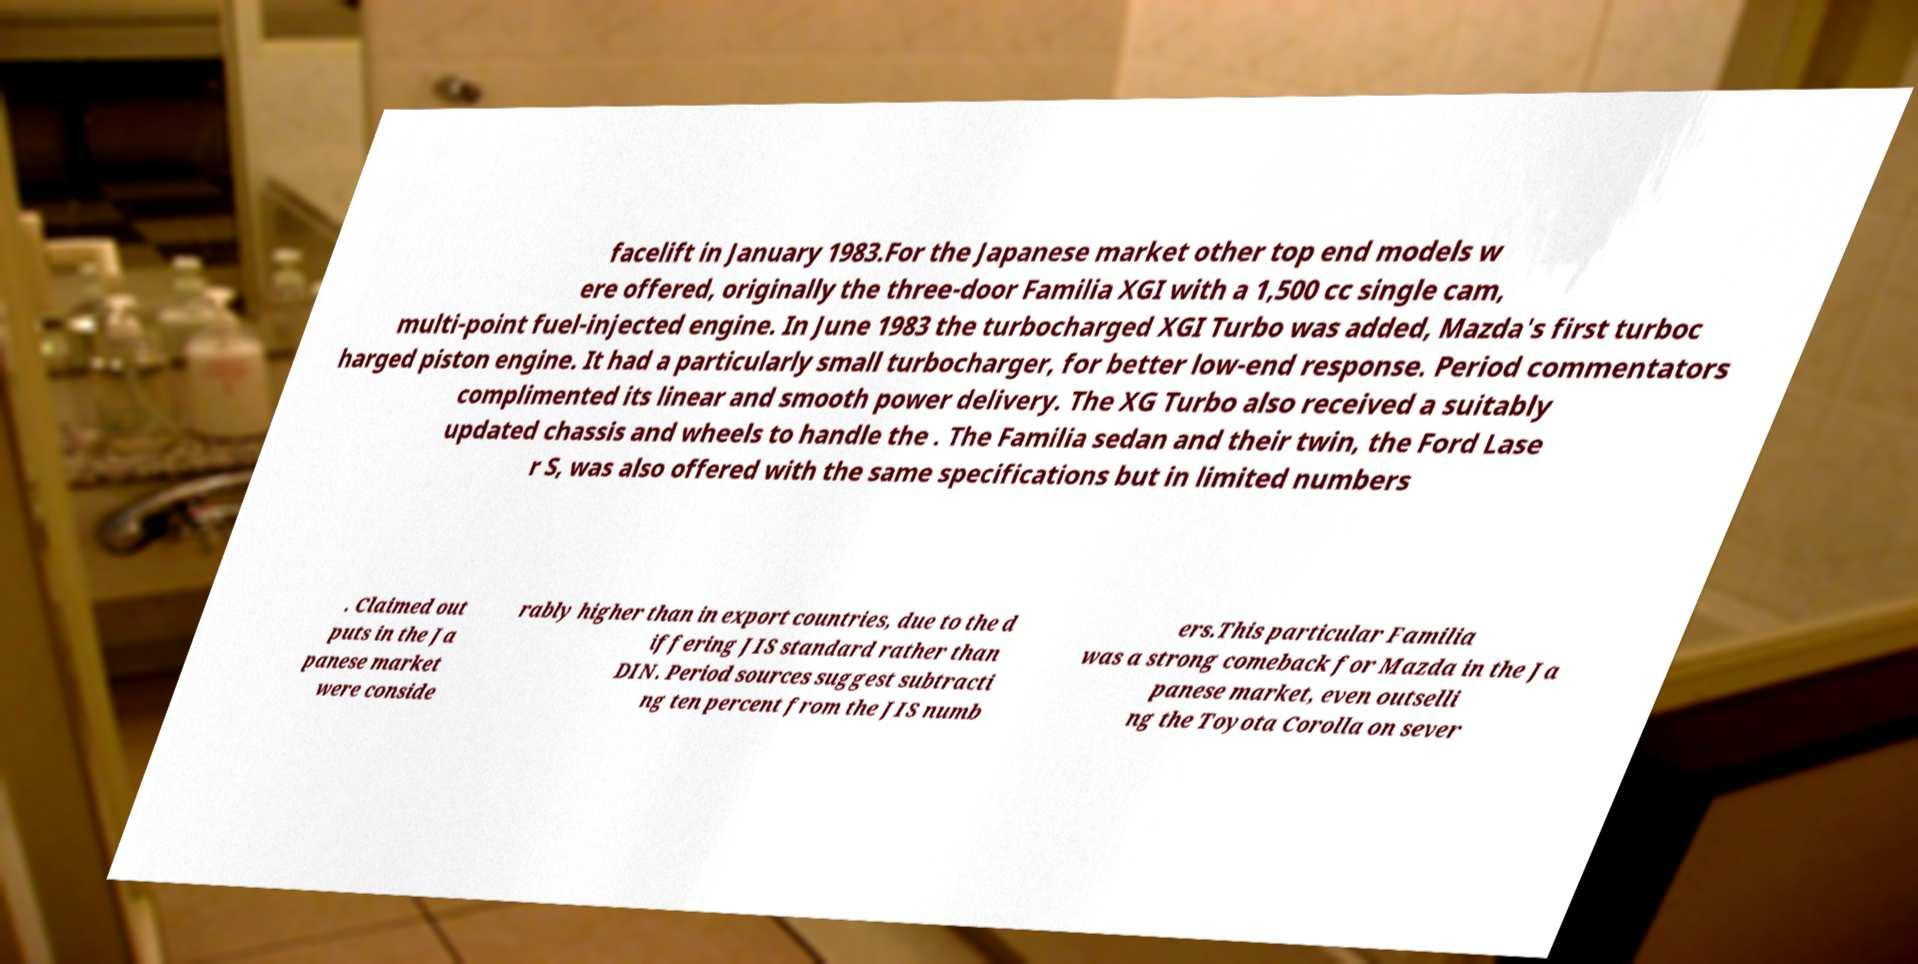What messages or text are displayed in this image? I need them in a readable, typed format. facelift in January 1983.For the Japanese market other top end models w ere offered, originally the three-door Familia XGI with a 1,500 cc single cam, multi-point fuel-injected engine. In June 1983 the turbocharged XGI Turbo was added, Mazda's first turboc harged piston engine. It had a particularly small turbocharger, for better low-end response. Period commentators complimented its linear and smooth power delivery. The XG Turbo also received a suitably updated chassis and wheels to handle the . The Familia sedan and their twin, the Ford Lase r S, was also offered with the same specifications but in limited numbers . Claimed out puts in the Ja panese market were conside rably higher than in export countries, due to the d iffering JIS standard rather than DIN. Period sources suggest subtracti ng ten percent from the JIS numb ers.This particular Familia was a strong comeback for Mazda in the Ja panese market, even outselli ng the Toyota Corolla on sever 